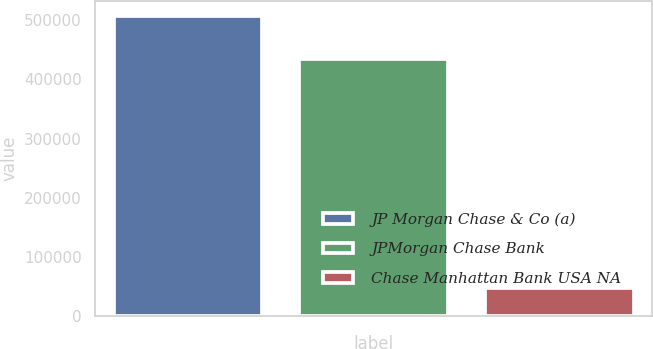Convert chart to OTSL. <chart><loc_0><loc_0><loc_500><loc_500><bar_chart><fcel>JP Morgan Chase & Co (a)<fcel>JPMorgan Chase Bank<fcel>Chase Manhattan Bank USA NA<nl><fcel>507456<fcel>434218<fcel>48030<nl></chart> 